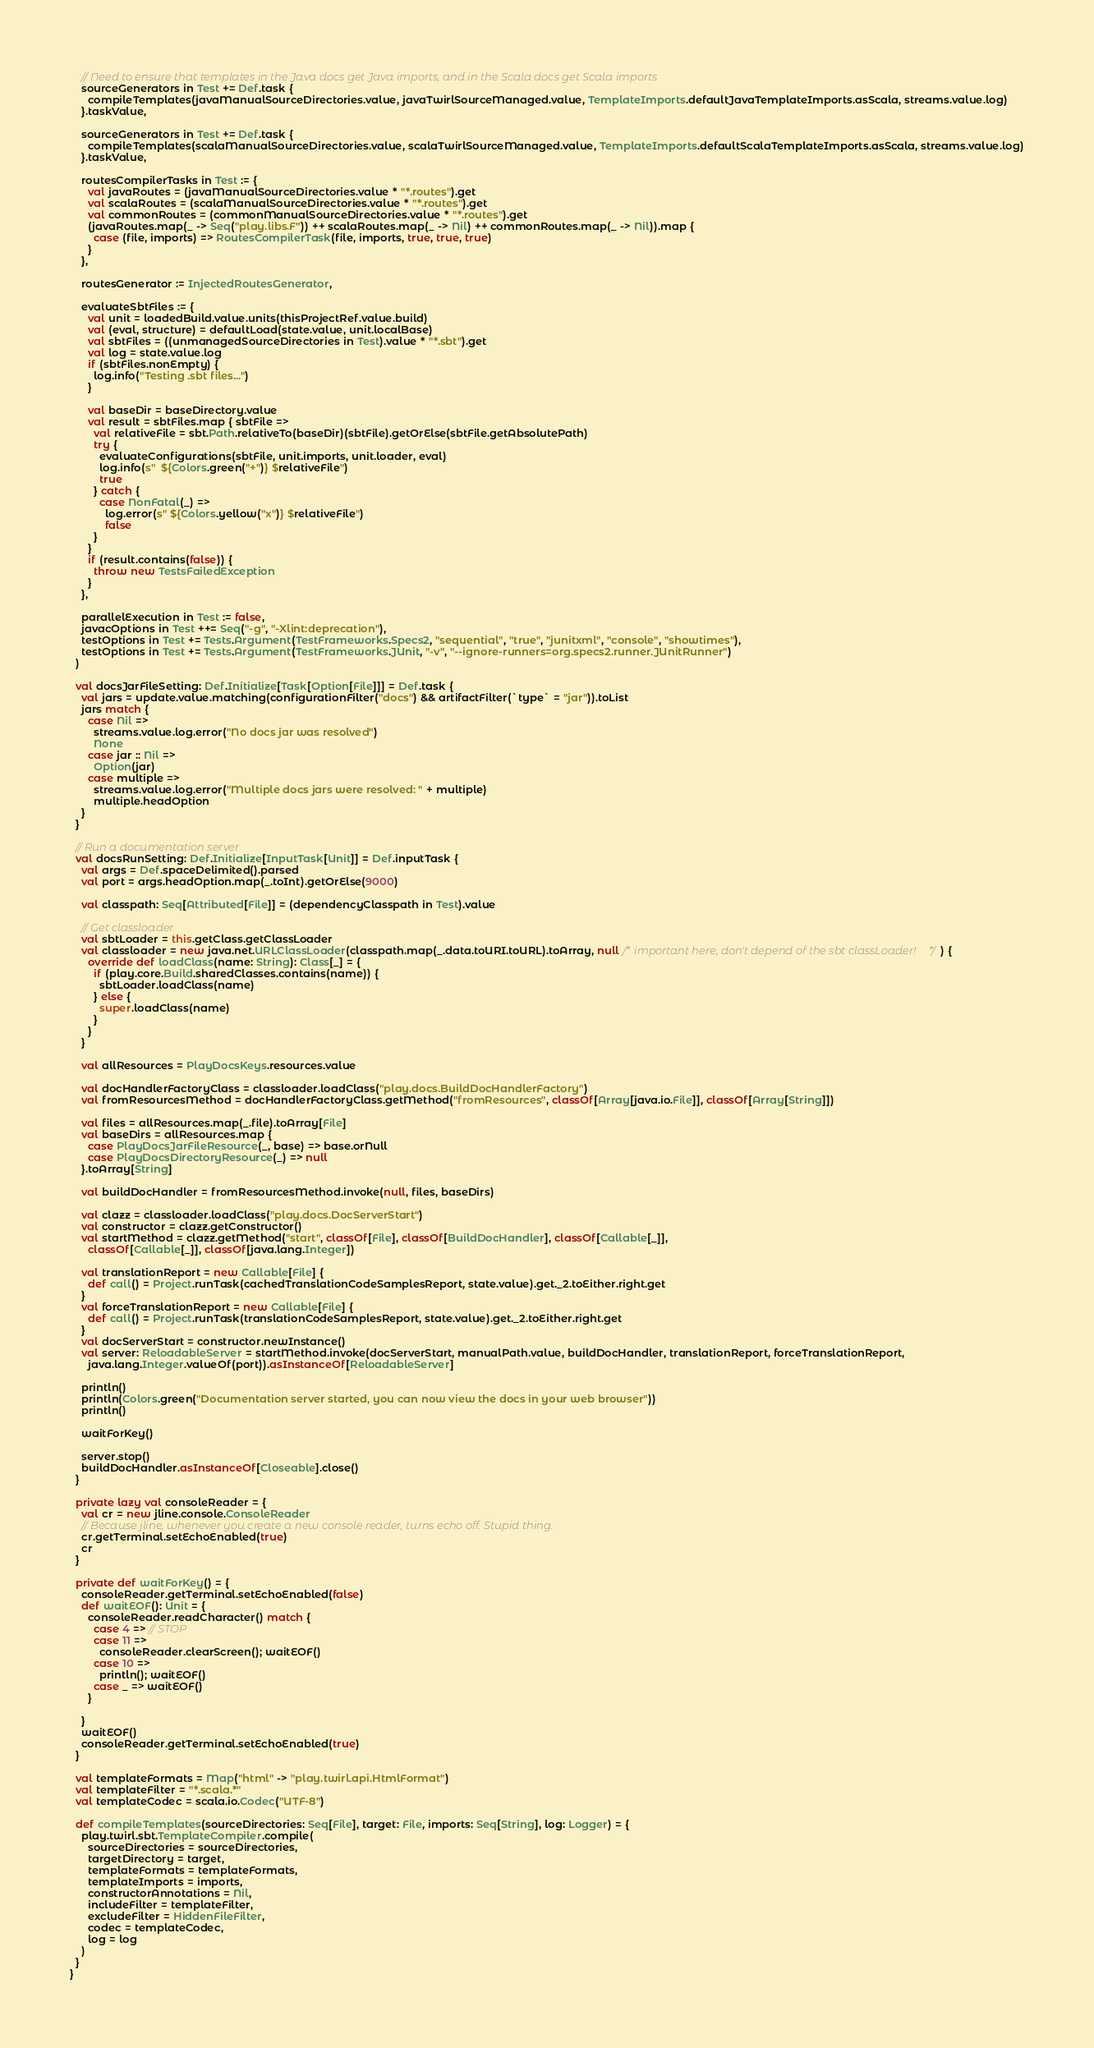Convert code to text. <code><loc_0><loc_0><loc_500><loc_500><_Scala_>    // Need to ensure that templates in the Java docs get Java imports, and in the Scala docs get Scala imports
    sourceGenerators in Test += Def.task {
      compileTemplates(javaManualSourceDirectories.value, javaTwirlSourceManaged.value, TemplateImports.defaultJavaTemplateImports.asScala, streams.value.log)
    }.taskValue,

    sourceGenerators in Test += Def.task {
      compileTemplates(scalaManualSourceDirectories.value, scalaTwirlSourceManaged.value, TemplateImports.defaultScalaTemplateImports.asScala, streams.value.log)
    }.taskValue,

    routesCompilerTasks in Test := {
      val javaRoutes = (javaManualSourceDirectories.value * "*.routes").get
      val scalaRoutes = (scalaManualSourceDirectories.value * "*.routes").get
      val commonRoutes = (commonManualSourceDirectories.value * "*.routes").get
      (javaRoutes.map(_ -> Seq("play.libs.F")) ++ scalaRoutes.map(_ -> Nil) ++ commonRoutes.map(_ -> Nil)).map {
        case (file, imports) => RoutesCompilerTask(file, imports, true, true, true)
      }
    },

    routesGenerator := InjectedRoutesGenerator,

    evaluateSbtFiles := {
      val unit = loadedBuild.value.units(thisProjectRef.value.build)
      val (eval, structure) = defaultLoad(state.value, unit.localBase)
      val sbtFiles = ((unmanagedSourceDirectories in Test).value * "*.sbt").get
      val log = state.value.log
      if (sbtFiles.nonEmpty) {
        log.info("Testing .sbt files...")
      }

      val baseDir = baseDirectory.value
      val result = sbtFiles.map { sbtFile =>
        val relativeFile = sbt.Path.relativeTo(baseDir)(sbtFile).getOrElse(sbtFile.getAbsolutePath)
        try {
          evaluateConfigurations(sbtFile, unit.imports, unit.loader, eval)
          log.info(s"  ${Colors.green("+")} $relativeFile")
          true
        } catch {
          case NonFatal(_) =>
            log.error(s" ${Colors.yellow("x")} $relativeFile")
            false
        }
      }
      if (result.contains(false)) {
        throw new TestsFailedException
      }
    },

    parallelExecution in Test := false,
    javacOptions in Test ++= Seq("-g", "-Xlint:deprecation"),
    testOptions in Test += Tests.Argument(TestFrameworks.Specs2, "sequential", "true", "junitxml", "console", "showtimes"),
    testOptions in Test += Tests.Argument(TestFrameworks.JUnit, "-v", "--ignore-runners=org.specs2.runner.JUnitRunner")
  )

  val docsJarFileSetting: Def.Initialize[Task[Option[File]]] = Def.task {
    val jars = update.value.matching(configurationFilter("docs") && artifactFilter(`type` = "jar")).toList
    jars match {
      case Nil =>
        streams.value.log.error("No docs jar was resolved")
        None
      case jar :: Nil =>
        Option(jar)
      case multiple =>
        streams.value.log.error("Multiple docs jars were resolved: " + multiple)
        multiple.headOption
    }
  }

  // Run a documentation server
  val docsRunSetting: Def.Initialize[InputTask[Unit]] = Def.inputTask {
    val args = Def.spaceDelimited().parsed
    val port = args.headOption.map(_.toInt).getOrElse(9000)

    val classpath: Seq[Attributed[File]] = (dependencyClasspath in Test).value

    // Get classloader
    val sbtLoader = this.getClass.getClassLoader
    val classloader = new java.net.URLClassLoader(classpath.map(_.data.toURI.toURL).toArray, null /* important here, don't depend of the sbt classLoader! */ ) {
      override def loadClass(name: String): Class[_] = {
        if (play.core.Build.sharedClasses.contains(name)) {
          sbtLoader.loadClass(name)
        } else {
          super.loadClass(name)
        }
      }
    }

    val allResources = PlayDocsKeys.resources.value

    val docHandlerFactoryClass = classloader.loadClass("play.docs.BuildDocHandlerFactory")
    val fromResourcesMethod = docHandlerFactoryClass.getMethod("fromResources", classOf[Array[java.io.File]], classOf[Array[String]])

    val files = allResources.map(_.file).toArray[File]
    val baseDirs = allResources.map {
      case PlayDocsJarFileResource(_, base) => base.orNull
      case PlayDocsDirectoryResource(_) => null
    }.toArray[String]

    val buildDocHandler = fromResourcesMethod.invoke(null, files, baseDirs)

    val clazz = classloader.loadClass("play.docs.DocServerStart")
    val constructor = clazz.getConstructor()
    val startMethod = clazz.getMethod("start", classOf[File], classOf[BuildDocHandler], classOf[Callable[_]],
      classOf[Callable[_]], classOf[java.lang.Integer])

    val translationReport = new Callable[File] {
      def call() = Project.runTask(cachedTranslationCodeSamplesReport, state.value).get._2.toEither.right.get
    }
    val forceTranslationReport = new Callable[File] {
      def call() = Project.runTask(translationCodeSamplesReport, state.value).get._2.toEither.right.get
    }
    val docServerStart = constructor.newInstance()
    val server: ReloadableServer = startMethod.invoke(docServerStart, manualPath.value, buildDocHandler, translationReport, forceTranslationReport,
      java.lang.Integer.valueOf(port)).asInstanceOf[ReloadableServer]

    println()
    println(Colors.green("Documentation server started, you can now view the docs in your web browser"))
    println()

    waitForKey()

    server.stop()
    buildDocHandler.asInstanceOf[Closeable].close()
  }

  private lazy val consoleReader = {
    val cr = new jline.console.ConsoleReader
    // Because jline, whenever you create a new console reader, turns echo off. Stupid thing.
    cr.getTerminal.setEchoEnabled(true)
    cr
  }

  private def waitForKey() = {
    consoleReader.getTerminal.setEchoEnabled(false)
    def waitEOF(): Unit = {
      consoleReader.readCharacter() match {
        case 4 => // STOP
        case 11 =>
          consoleReader.clearScreen(); waitEOF()
        case 10 =>
          println(); waitEOF()
        case _ => waitEOF()
      }

    }
    waitEOF()
    consoleReader.getTerminal.setEchoEnabled(true)
  }

  val templateFormats = Map("html" -> "play.twirl.api.HtmlFormat")
  val templateFilter = "*.scala.*"
  val templateCodec = scala.io.Codec("UTF-8")

  def compileTemplates(sourceDirectories: Seq[File], target: File, imports: Seq[String], log: Logger) = {
    play.twirl.sbt.TemplateCompiler.compile(
      sourceDirectories = sourceDirectories,
      targetDirectory = target,
      templateFormats = templateFormats,
      templateImports = imports,
      constructorAnnotations = Nil,
      includeFilter = templateFilter,
      excludeFilter = HiddenFileFilter,
      codec = templateCodec,
      log = log
    )
  }
}
</code> 